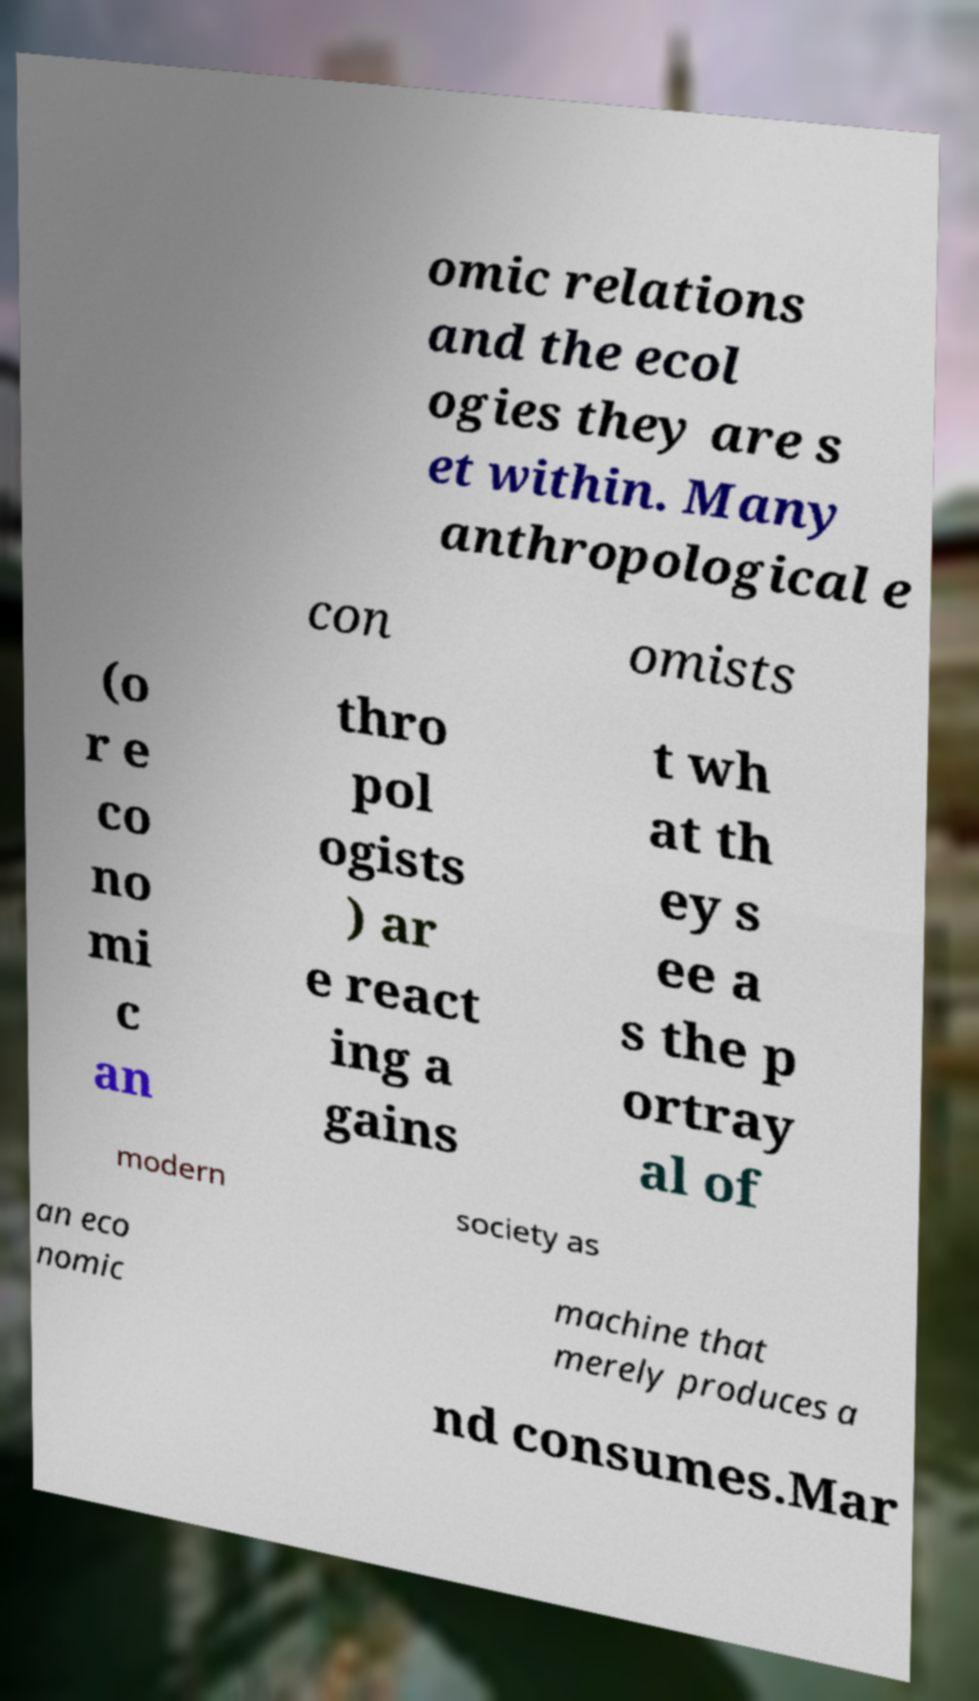For documentation purposes, I need the text within this image transcribed. Could you provide that? omic relations and the ecol ogies they are s et within. Many anthropological e con omists (o r e co no mi c an thro pol ogists ) ar e react ing a gains t wh at th ey s ee a s the p ortray al of modern society as an eco nomic machine that merely produces a nd consumes.Mar 